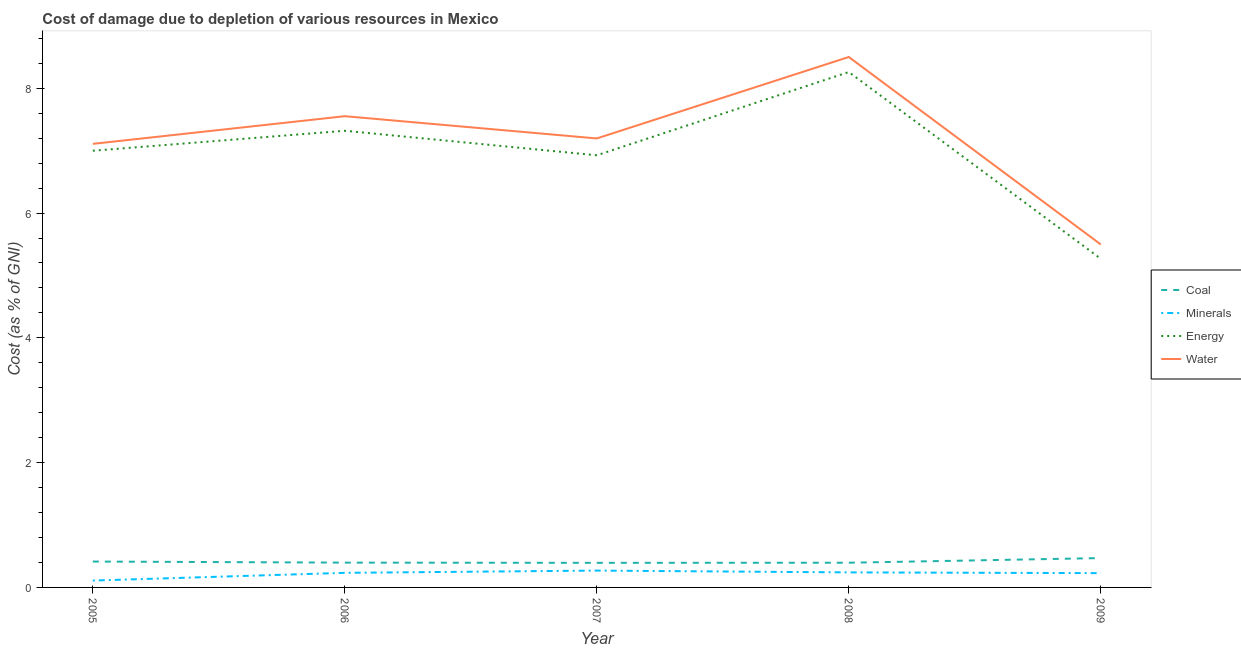How many different coloured lines are there?
Give a very brief answer. 4. Does the line corresponding to cost of damage due to depletion of minerals intersect with the line corresponding to cost of damage due to depletion of energy?
Offer a very short reply. No. Is the number of lines equal to the number of legend labels?
Offer a terse response. Yes. What is the cost of damage due to depletion of minerals in 2005?
Your answer should be very brief. 0.11. Across all years, what is the maximum cost of damage due to depletion of minerals?
Offer a very short reply. 0.27. Across all years, what is the minimum cost of damage due to depletion of energy?
Your response must be concise. 5.27. What is the total cost of damage due to depletion of coal in the graph?
Your answer should be very brief. 2.07. What is the difference between the cost of damage due to depletion of energy in 2006 and that in 2008?
Make the answer very short. -0.94. What is the difference between the cost of damage due to depletion of coal in 2007 and the cost of damage due to depletion of minerals in 2008?
Your answer should be very brief. 0.15. What is the average cost of damage due to depletion of water per year?
Provide a succinct answer. 7.17. In the year 2006, what is the difference between the cost of damage due to depletion of energy and cost of damage due to depletion of water?
Provide a succinct answer. -0.23. In how many years, is the cost of damage due to depletion of minerals greater than 7.2 %?
Provide a succinct answer. 0. What is the ratio of the cost of damage due to depletion of energy in 2005 to that in 2006?
Provide a succinct answer. 0.96. Is the cost of damage due to depletion of coal in 2005 less than that in 2006?
Provide a short and direct response. No. Is the difference between the cost of damage due to depletion of water in 2006 and 2009 greater than the difference between the cost of damage due to depletion of minerals in 2006 and 2009?
Give a very brief answer. Yes. What is the difference between the highest and the second highest cost of damage due to depletion of energy?
Ensure brevity in your answer.  0.94. What is the difference between the highest and the lowest cost of damage due to depletion of water?
Ensure brevity in your answer.  3. Is the sum of the cost of damage due to depletion of water in 2005 and 2009 greater than the maximum cost of damage due to depletion of minerals across all years?
Your answer should be very brief. Yes. Is it the case that in every year, the sum of the cost of damage due to depletion of coal and cost of damage due to depletion of minerals is greater than the cost of damage due to depletion of energy?
Provide a short and direct response. No. Is the cost of damage due to depletion of minerals strictly greater than the cost of damage due to depletion of coal over the years?
Make the answer very short. No. What is the difference between two consecutive major ticks on the Y-axis?
Your answer should be very brief. 2. Where does the legend appear in the graph?
Give a very brief answer. Center right. How are the legend labels stacked?
Offer a very short reply. Vertical. What is the title of the graph?
Provide a succinct answer. Cost of damage due to depletion of various resources in Mexico . What is the label or title of the Y-axis?
Provide a short and direct response. Cost (as % of GNI). What is the Cost (as % of GNI) of Coal in 2005?
Make the answer very short. 0.41. What is the Cost (as % of GNI) of Minerals in 2005?
Your answer should be very brief. 0.11. What is the Cost (as % of GNI) in Energy in 2005?
Your answer should be compact. 7. What is the Cost (as % of GNI) in Water in 2005?
Provide a succinct answer. 7.11. What is the Cost (as % of GNI) of Coal in 2006?
Keep it short and to the point. 0.4. What is the Cost (as % of GNI) of Minerals in 2006?
Your answer should be very brief. 0.23. What is the Cost (as % of GNI) in Energy in 2006?
Make the answer very short. 7.32. What is the Cost (as % of GNI) of Water in 2006?
Provide a short and direct response. 7.55. What is the Cost (as % of GNI) in Coal in 2007?
Your answer should be compact. 0.39. What is the Cost (as % of GNI) in Minerals in 2007?
Keep it short and to the point. 0.27. What is the Cost (as % of GNI) of Energy in 2007?
Offer a terse response. 6.93. What is the Cost (as % of GNI) of Water in 2007?
Your answer should be compact. 7.2. What is the Cost (as % of GNI) of Coal in 2008?
Provide a short and direct response. 0.4. What is the Cost (as % of GNI) in Minerals in 2008?
Provide a short and direct response. 0.24. What is the Cost (as % of GNI) in Energy in 2008?
Provide a short and direct response. 8.26. What is the Cost (as % of GNI) of Water in 2008?
Ensure brevity in your answer.  8.5. What is the Cost (as % of GNI) of Coal in 2009?
Ensure brevity in your answer.  0.47. What is the Cost (as % of GNI) in Minerals in 2009?
Provide a short and direct response. 0.23. What is the Cost (as % of GNI) in Energy in 2009?
Your answer should be compact. 5.27. What is the Cost (as % of GNI) of Water in 2009?
Your response must be concise. 5.5. Across all years, what is the maximum Cost (as % of GNI) in Coal?
Make the answer very short. 0.47. Across all years, what is the maximum Cost (as % of GNI) of Minerals?
Provide a succinct answer. 0.27. Across all years, what is the maximum Cost (as % of GNI) in Energy?
Make the answer very short. 8.26. Across all years, what is the maximum Cost (as % of GNI) in Water?
Offer a very short reply. 8.5. Across all years, what is the minimum Cost (as % of GNI) in Coal?
Your answer should be compact. 0.39. Across all years, what is the minimum Cost (as % of GNI) in Minerals?
Ensure brevity in your answer.  0.11. Across all years, what is the minimum Cost (as % of GNI) in Energy?
Your response must be concise. 5.27. Across all years, what is the minimum Cost (as % of GNI) in Water?
Keep it short and to the point. 5.5. What is the total Cost (as % of GNI) in Coal in the graph?
Give a very brief answer. 2.07. What is the total Cost (as % of GNI) of Minerals in the graph?
Keep it short and to the point. 1.08. What is the total Cost (as % of GNI) in Energy in the graph?
Offer a very short reply. 34.77. What is the total Cost (as % of GNI) of Water in the graph?
Offer a very short reply. 35.86. What is the difference between the Cost (as % of GNI) in Coal in 2005 and that in 2006?
Give a very brief answer. 0.02. What is the difference between the Cost (as % of GNI) in Minerals in 2005 and that in 2006?
Give a very brief answer. -0.12. What is the difference between the Cost (as % of GNI) in Energy in 2005 and that in 2006?
Offer a terse response. -0.32. What is the difference between the Cost (as % of GNI) of Water in 2005 and that in 2006?
Offer a very short reply. -0.44. What is the difference between the Cost (as % of GNI) of Coal in 2005 and that in 2007?
Ensure brevity in your answer.  0.02. What is the difference between the Cost (as % of GNI) of Minerals in 2005 and that in 2007?
Your response must be concise. -0.16. What is the difference between the Cost (as % of GNI) of Energy in 2005 and that in 2007?
Keep it short and to the point. 0.07. What is the difference between the Cost (as % of GNI) in Water in 2005 and that in 2007?
Ensure brevity in your answer.  -0.09. What is the difference between the Cost (as % of GNI) of Coal in 2005 and that in 2008?
Ensure brevity in your answer.  0.02. What is the difference between the Cost (as % of GNI) in Minerals in 2005 and that in 2008?
Offer a terse response. -0.13. What is the difference between the Cost (as % of GNI) of Energy in 2005 and that in 2008?
Offer a terse response. -1.26. What is the difference between the Cost (as % of GNI) in Water in 2005 and that in 2008?
Give a very brief answer. -1.39. What is the difference between the Cost (as % of GNI) in Coal in 2005 and that in 2009?
Offer a terse response. -0.06. What is the difference between the Cost (as % of GNI) of Minerals in 2005 and that in 2009?
Ensure brevity in your answer.  -0.12. What is the difference between the Cost (as % of GNI) in Energy in 2005 and that in 2009?
Offer a very short reply. 1.73. What is the difference between the Cost (as % of GNI) of Water in 2005 and that in 2009?
Make the answer very short. 1.61. What is the difference between the Cost (as % of GNI) of Coal in 2006 and that in 2007?
Provide a short and direct response. 0. What is the difference between the Cost (as % of GNI) of Minerals in 2006 and that in 2007?
Keep it short and to the point. -0.04. What is the difference between the Cost (as % of GNI) of Energy in 2006 and that in 2007?
Give a very brief answer. 0.39. What is the difference between the Cost (as % of GNI) in Water in 2006 and that in 2007?
Your answer should be compact. 0.36. What is the difference between the Cost (as % of GNI) of Coal in 2006 and that in 2008?
Make the answer very short. 0. What is the difference between the Cost (as % of GNI) of Minerals in 2006 and that in 2008?
Your response must be concise. -0.01. What is the difference between the Cost (as % of GNI) of Energy in 2006 and that in 2008?
Give a very brief answer. -0.94. What is the difference between the Cost (as % of GNI) in Water in 2006 and that in 2008?
Provide a short and direct response. -0.95. What is the difference between the Cost (as % of GNI) in Coal in 2006 and that in 2009?
Offer a very short reply. -0.07. What is the difference between the Cost (as % of GNI) of Minerals in 2006 and that in 2009?
Your response must be concise. 0. What is the difference between the Cost (as % of GNI) in Energy in 2006 and that in 2009?
Your response must be concise. 2.05. What is the difference between the Cost (as % of GNI) in Water in 2006 and that in 2009?
Your answer should be compact. 2.06. What is the difference between the Cost (as % of GNI) of Coal in 2007 and that in 2008?
Ensure brevity in your answer.  -0. What is the difference between the Cost (as % of GNI) of Minerals in 2007 and that in 2008?
Provide a short and direct response. 0.03. What is the difference between the Cost (as % of GNI) of Energy in 2007 and that in 2008?
Make the answer very short. -1.33. What is the difference between the Cost (as % of GNI) of Water in 2007 and that in 2008?
Give a very brief answer. -1.31. What is the difference between the Cost (as % of GNI) in Coal in 2007 and that in 2009?
Offer a very short reply. -0.08. What is the difference between the Cost (as % of GNI) of Minerals in 2007 and that in 2009?
Ensure brevity in your answer.  0.04. What is the difference between the Cost (as % of GNI) of Energy in 2007 and that in 2009?
Offer a terse response. 1.66. What is the difference between the Cost (as % of GNI) in Water in 2007 and that in 2009?
Your answer should be compact. 1.7. What is the difference between the Cost (as % of GNI) of Coal in 2008 and that in 2009?
Give a very brief answer. -0.07. What is the difference between the Cost (as % of GNI) of Minerals in 2008 and that in 2009?
Your answer should be very brief. 0.01. What is the difference between the Cost (as % of GNI) of Energy in 2008 and that in 2009?
Keep it short and to the point. 2.99. What is the difference between the Cost (as % of GNI) in Water in 2008 and that in 2009?
Your answer should be very brief. 3. What is the difference between the Cost (as % of GNI) in Coal in 2005 and the Cost (as % of GNI) in Minerals in 2006?
Provide a short and direct response. 0.18. What is the difference between the Cost (as % of GNI) in Coal in 2005 and the Cost (as % of GNI) in Energy in 2006?
Give a very brief answer. -6.9. What is the difference between the Cost (as % of GNI) of Coal in 2005 and the Cost (as % of GNI) of Water in 2006?
Provide a succinct answer. -7.14. What is the difference between the Cost (as % of GNI) in Minerals in 2005 and the Cost (as % of GNI) in Energy in 2006?
Make the answer very short. -7.21. What is the difference between the Cost (as % of GNI) of Minerals in 2005 and the Cost (as % of GNI) of Water in 2006?
Offer a very short reply. -7.44. What is the difference between the Cost (as % of GNI) of Energy in 2005 and the Cost (as % of GNI) of Water in 2006?
Your answer should be compact. -0.55. What is the difference between the Cost (as % of GNI) of Coal in 2005 and the Cost (as % of GNI) of Minerals in 2007?
Keep it short and to the point. 0.14. What is the difference between the Cost (as % of GNI) of Coal in 2005 and the Cost (as % of GNI) of Energy in 2007?
Your answer should be very brief. -6.51. What is the difference between the Cost (as % of GNI) of Coal in 2005 and the Cost (as % of GNI) of Water in 2007?
Offer a terse response. -6.78. What is the difference between the Cost (as % of GNI) of Minerals in 2005 and the Cost (as % of GNI) of Energy in 2007?
Make the answer very short. -6.82. What is the difference between the Cost (as % of GNI) of Minerals in 2005 and the Cost (as % of GNI) of Water in 2007?
Your answer should be compact. -7.09. What is the difference between the Cost (as % of GNI) in Energy in 2005 and the Cost (as % of GNI) in Water in 2007?
Make the answer very short. -0.2. What is the difference between the Cost (as % of GNI) in Coal in 2005 and the Cost (as % of GNI) in Minerals in 2008?
Ensure brevity in your answer.  0.17. What is the difference between the Cost (as % of GNI) in Coal in 2005 and the Cost (as % of GNI) in Energy in 2008?
Offer a very short reply. -7.85. What is the difference between the Cost (as % of GNI) of Coal in 2005 and the Cost (as % of GNI) of Water in 2008?
Make the answer very short. -8.09. What is the difference between the Cost (as % of GNI) in Minerals in 2005 and the Cost (as % of GNI) in Energy in 2008?
Your answer should be very brief. -8.15. What is the difference between the Cost (as % of GNI) in Minerals in 2005 and the Cost (as % of GNI) in Water in 2008?
Your answer should be compact. -8.39. What is the difference between the Cost (as % of GNI) of Energy in 2005 and the Cost (as % of GNI) of Water in 2008?
Offer a terse response. -1.5. What is the difference between the Cost (as % of GNI) of Coal in 2005 and the Cost (as % of GNI) of Minerals in 2009?
Offer a very short reply. 0.19. What is the difference between the Cost (as % of GNI) of Coal in 2005 and the Cost (as % of GNI) of Energy in 2009?
Provide a short and direct response. -4.85. What is the difference between the Cost (as % of GNI) in Coal in 2005 and the Cost (as % of GNI) in Water in 2009?
Provide a succinct answer. -5.08. What is the difference between the Cost (as % of GNI) of Minerals in 2005 and the Cost (as % of GNI) of Energy in 2009?
Provide a succinct answer. -5.16. What is the difference between the Cost (as % of GNI) of Minerals in 2005 and the Cost (as % of GNI) of Water in 2009?
Give a very brief answer. -5.39. What is the difference between the Cost (as % of GNI) of Energy in 2005 and the Cost (as % of GNI) of Water in 2009?
Your response must be concise. 1.5. What is the difference between the Cost (as % of GNI) of Coal in 2006 and the Cost (as % of GNI) of Minerals in 2007?
Make the answer very short. 0.13. What is the difference between the Cost (as % of GNI) of Coal in 2006 and the Cost (as % of GNI) of Energy in 2007?
Ensure brevity in your answer.  -6.53. What is the difference between the Cost (as % of GNI) in Coal in 2006 and the Cost (as % of GNI) in Water in 2007?
Your answer should be very brief. -6.8. What is the difference between the Cost (as % of GNI) of Minerals in 2006 and the Cost (as % of GNI) of Energy in 2007?
Provide a short and direct response. -6.69. What is the difference between the Cost (as % of GNI) of Minerals in 2006 and the Cost (as % of GNI) of Water in 2007?
Your answer should be very brief. -6.96. What is the difference between the Cost (as % of GNI) in Energy in 2006 and the Cost (as % of GNI) in Water in 2007?
Provide a short and direct response. 0.12. What is the difference between the Cost (as % of GNI) in Coal in 2006 and the Cost (as % of GNI) in Minerals in 2008?
Offer a very short reply. 0.16. What is the difference between the Cost (as % of GNI) in Coal in 2006 and the Cost (as % of GNI) in Energy in 2008?
Ensure brevity in your answer.  -7.86. What is the difference between the Cost (as % of GNI) of Coal in 2006 and the Cost (as % of GNI) of Water in 2008?
Give a very brief answer. -8.1. What is the difference between the Cost (as % of GNI) in Minerals in 2006 and the Cost (as % of GNI) in Energy in 2008?
Provide a succinct answer. -8.03. What is the difference between the Cost (as % of GNI) in Minerals in 2006 and the Cost (as % of GNI) in Water in 2008?
Offer a very short reply. -8.27. What is the difference between the Cost (as % of GNI) in Energy in 2006 and the Cost (as % of GNI) in Water in 2008?
Your answer should be compact. -1.18. What is the difference between the Cost (as % of GNI) in Coal in 2006 and the Cost (as % of GNI) in Minerals in 2009?
Offer a very short reply. 0.17. What is the difference between the Cost (as % of GNI) in Coal in 2006 and the Cost (as % of GNI) in Energy in 2009?
Give a very brief answer. -4.87. What is the difference between the Cost (as % of GNI) in Coal in 2006 and the Cost (as % of GNI) in Water in 2009?
Give a very brief answer. -5.1. What is the difference between the Cost (as % of GNI) in Minerals in 2006 and the Cost (as % of GNI) in Energy in 2009?
Offer a terse response. -5.03. What is the difference between the Cost (as % of GNI) of Minerals in 2006 and the Cost (as % of GNI) of Water in 2009?
Provide a short and direct response. -5.26. What is the difference between the Cost (as % of GNI) in Energy in 2006 and the Cost (as % of GNI) in Water in 2009?
Offer a terse response. 1.82. What is the difference between the Cost (as % of GNI) in Coal in 2007 and the Cost (as % of GNI) in Minerals in 2008?
Provide a short and direct response. 0.15. What is the difference between the Cost (as % of GNI) in Coal in 2007 and the Cost (as % of GNI) in Energy in 2008?
Make the answer very short. -7.87. What is the difference between the Cost (as % of GNI) in Coal in 2007 and the Cost (as % of GNI) in Water in 2008?
Your answer should be compact. -8.11. What is the difference between the Cost (as % of GNI) in Minerals in 2007 and the Cost (as % of GNI) in Energy in 2008?
Keep it short and to the point. -7.99. What is the difference between the Cost (as % of GNI) of Minerals in 2007 and the Cost (as % of GNI) of Water in 2008?
Your answer should be very brief. -8.23. What is the difference between the Cost (as % of GNI) in Energy in 2007 and the Cost (as % of GNI) in Water in 2008?
Provide a succinct answer. -1.58. What is the difference between the Cost (as % of GNI) of Coal in 2007 and the Cost (as % of GNI) of Minerals in 2009?
Offer a terse response. 0.17. What is the difference between the Cost (as % of GNI) of Coal in 2007 and the Cost (as % of GNI) of Energy in 2009?
Your response must be concise. -4.87. What is the difference between the Cost (as % of GNI) of Coal in 2007 and the Cost (as % of GNI) of Water in 2009?
Ensure brevity in your answer.  -5.1. What is the difference between the Cost (as % of GNI) of Minerals in 2007 and the Cost (as % of GNI) of Energy in 2009?
Offer a terse response. -5. What is the difference between the Cost (as % of GNI) of Minerals in 2007 and the Cost (as % of GNI) of Water in 2009?
Provide a short and direct response. -5.23. What is the difference between the Cost (as % of GNI) in Energy in 2007 and the Cost (as % of GNI) in Water in 2009?
Your answer should be very brief. 1.43. What is the difference between the Cost (as % of GNI) in Coal in 2008 and the Cost (as % of GNI) in Minerals in 2009?
Ensure brevity in your answer.  0.17. What is the difference between the Cost (as % of GNI) of Coal in 2008 and the Cost (as % of GNI) of Energy in 2009?
Offer a very short reply. -4.87. What is the difference between the Cost (as % of GNI) in Coal in 2008 and the Cost (as % of GNI) in Water in 2009?
Your answer should be very brief. -5.1. What is the difference between the Cost (as % of GNI) of Minerals in 2008 and the Cost (as % of GNI) of Energy in 2009?
Your answer should be very brief. -5.03. What is the difference between the Cost (as % of GNI) in Minerals in 2008 and the Cost (as % of GNI) in Water in 2009?
Provide a short and direct response. -5.26. What is the difference between the Cost (as % of GNI) of Energy in 2008 and the Cost (as % of GNI) of Water in 2009?
Your answer should be very brief. 2.76. What is the average Cost (as % of GNI) of Coal per year?
Your answer should be very brief. 0.41. What is the average Cost (as % of GNI) in Minerals per year?
Offer a terse response. 0.22. What is the average Cost (as % of GNI) of Energy per year?
Offer a very short reply. 6.95. What is the average Cost (as % of GNI) in Water per year?
Your response must be concise. 7.17. In the year 2005, what is the difference between the Cost (as % of GNI) in Coal and Cost (as % of GNI) in Minerals?
Your response must be concise. 0.3. In the year 2005, what is the difference between the Cost (as % of GNI) of Coal and Cost (as % of GNI) of Energy?
Provide a succinct answer. -6.58. In the year 2005, what is the difference between the Cost (as % of GNI) of Coal and Cost (as % of GNI) of Water?
Give a very brief answer. -6.69. In the year 2005, what is the difference between the Cost (as % of GNI) of Minerals and Cost (as % of GNI) of Energy?
Give a very brief answer. -6.89. In the year 2005, what is the difference between the Cost (as % of GNI) in Minerals and Cost (as % of GNI) in Water?
Provide a short and direct response. -7. In the year 2005, what is the difference between the Cost (as % of GNI) in Energy and Cost (as % of GNI) in Water?
Ensure brevity in your answer.  -0.11. In the year 2006, what is the difference between the Cost (as % of GNI) of Coal and Cost (as % of GNI) of Minerals?
Your response must be concise. 0.16. In the year 2006, what is the difference between the Cost (as % of GNI) of Coal and Cost (as % of GNI) of Energy?
Your response must be concise. -6.92. In the year 2006, what is the difference between the Cost (as % of GNI) in Coal and Cost (as % of GNI) in Water?
Your answer should be compact. -7.16. In the year 2006, what is the difference between the Cost (as % of GNI) of Minerals and Cost (as % of GNI) of Energy?
Make the answer very short. -7.09. In the year 2006, what is the difference between the Cost (as % of GNI) in Minerals and Cost (as % of GNI) in Water?
Ensure brevity in your answer.  -7.32. In the year 2006, what is the difference between the Cost (as % of GNI) in Energy and Cost (as % of GNI) in Water?
Keep it short and to the point. -0.23. In the year 2007, what is the difference between the Cost (as % of GNI) of Coal and Cost (as % of GNI) of Minerals?
Provide a short and direct response. 0.12. In the year 2007, what is the difference between the Cost (as % of GNI) in Coal and Cost (as % of GNI) in Energy?
Give a very brief answer. -6.53. In the year 2007, what is the difference between the Cost (as % of GNI) of Coal and Cost (as % of GNI) of Water?
Keep it short and to the point. -6.8. In the year 2007, what is the difference between the Cost (as % of GNI) of Minerals and Cost (as % of GNI) of Energy?
Keep it short and to the point. -6.66. In the year 2007, what is the difference between the Cost (as % of GNI) in Minerals and Cost (as % of GNI) in Water?
Make the answer very short. -6.93. In the year 2007, what is the difference between the Cost (as % of GNI) of Energy and Cost (as % of GNI) of Water?
Your answer should be compact. -0.27. In the year 2008, what is the difference between the Cost (as % of GNI) of Coal and Cost (as % of GNI) of Minerals?
Ensure brevity in your answer.  0.15. In the year 2008, what is the difference between the Cost (as % of GNI) of Coal and Cost (as % of GNI) of Energy?
Offer a very short reply. -7.86. In the year 2008, what is the difference between the Cost (as % of GNI) in Coal and Cost (as % of GNI) in Water?
Offer a terse response. -8.11. In the year 2008, what is the difference between the Cost (as % of GNI) of Minerals and Cost (as % of GNI) of Energy?
Provide a succinct answer. -8.02. In the year 2008, what is the difference between the Cost (as % of GNI) in Minerals and Cost (as % of GNI) in Water?
Your answer should be very brief. -8.26. In the year 2008, what is the difference between the Cost (as % of GNI) of Energy and Cost (as % of GNI) of Water?
Make the answer very short. -0.24. In the year 2009, what is the difference between the Cost (as % of GNI) of Coal and Cost (as % of GNI) of Minerals?
Offer a terse response. 0.24. In the year 2009, what is the difference between the Cost (as % of GNI) in Coal and Cost (as % of GNI) in Energy?
Provide a short and direct response. -4.8. In the year 2009, what is the difference between the Cost (as % of GNI) in Coal and Cost (as % of GNI) in Water?
Provide a succinct answer. -5.03. In the year 2009, what is the difference between the Cost (as % of GNI) in Minerals and Cost (as % of GNI) in Energy?
Give a very brief answer. -5.04. In the year 2009, what is the difference between the Cost (as % of GNI) of Minerals and Cost (as % of GNI) of Water?
Your response must be concise. -5.27. In the year 2009, what is the difference between the Cost (as % of GNI) of Energy and Cost (as % of GNI) of Water?
Ensure brevity in your answer.  -0.23. What is the ratio of the Cost (as % of GNI) in Coal in 2005 to that in 2006?
Offer a very short reply. 1.04. What is the ratio of the Cost (as % of GNI) in Minerals in 2005 to that in 2006?
Ensure brevity in your answer.  0.47. What is the ratio of the Cost (as % of GNI) of Energy in 2005 to that in 2006?
Your answer should be compact. 0.96. What is the ratio of the Cost (as % of GNI) in Water in 2005 to that in 2006?
Provide a short and direct response. 0.94. What is the ratio of the Cost (as % of GNI) of Coal in 2005 to that in 2007?
Your response must be concise. 1.05. What is the ratio of the Cost (as % of GNI) of Minerals in 2005 to that in 2007?
Provide a succinct answer. 0.41. What is the ratio of the Cost (as % of GNI) in Energy in 2005 to that in 2007?
Give a very brief answer. 1.01. What is the ratio of the Cost (as % of GNI) in Water in 2005 to that in 2007?
Your answer should be very brief. 0.99. What is the ratio of the Cost (as % of GNI) of Coal in 2005 to that in 2008?
Your answer should be very brief. 1.05. What is the ratio of the Cost (as % of GNI) of Minerals in 2005 to that in 2008?
Keep it short and to the point. 0.46. What is the ratio of the Cost (as % of GNI) of Energy in 2005 to that in 2008?
Provide a succinct answer. 0.85. What is the ratio of the Cost (as % of GNI) of Water in 2005 to that in 2008?
Give a very brief answer. 0.84. What is the ratio of the Cost (as % of GNI) in Coal in 2005 to that in 2009?
Keep it short and to the point. 0.88. What is the ratio of the Cost (as % of GNI) in Minerals in 2005 to that in 2009?
Offer a very short reply. 0.48. What is the ratio of the Cost (as % of GNI) of Energy in 2005 to that in 2009?
Offer a terse response. 1.33. What is the ratio of the Cost (as % of GNI) in Water in 2005 to that in 2009?
Offer a terse response. 1.29. What is the ratio of the Cost (as % of GNI) in Coal in 2006 to that in 2007?
Your response must be concise. 1.01. What is the ratio of the Cost (as % of GNI) of Minerals in 2006 to that in 2007?
Give a very brief answer. 0.87. What is the ratio of the Cost (as % of GNI) of Energy in 2006 to that in 2007?
Your response must be concise. 1.06. What is the ratio of the Cost (as % of GNI) of Water in 2006 to that in 2007?
Make the answer very short. 1.05. What is the ratio of the Cost (as % of GNI) in Minerals in 2006 to that in 2008?
Your response must be concise. 0.97. What is the ratio of the Cost (as % of GNI) of Energy in 2006 to that in 2008?
Your response must be concise. 0.89. What is the ratio of the Cost (as % of GNI) of Water in 2006 to that in 2008?
Your answer should be very brief. 0.89. What is the ratio of the Cost (as % of GNI) in Coal in 2006 to that in 2009?
Offer a terse response. 0.84. What is the ratio of the Cost (as % of GNI) in Minerals in 2006 to that in 2009?
Keep it short and to the point. 1.02. What is the ratio of the Cost (as % of GNI) in Energy in 2006 to that in 2009?
Offer a very short reply. 1.39. What is the ratio of the Cost (as % of GNI) of Water in 2006 to that in 2009?
Give a very brief answer. 1.37. What is the ratio of the Cost (as % of GNI) of Coal in 2007 to that in 2008?
Provide a succinct answer. 1. What is the ratio of the Cost (as % of GNI) in Minerals in 2007 to that in 2008?
Offer a very short reply. 1.12. What is the ratio of the Cost (as % of GNI) in Energy in 2007 to that in 2008?
Make the answer very short. 0.84. What is the ratio of the Cost (as % of GNI) of Water in 2007 to that in 2008?
Make the answer very short. 0.85. What is the ratio of the Cost (as % of GNI) in Coal in 2007 to that in 2009?
Offer a very short reply. 0.84. What is the ratio of the Cost (as % of GNI) in Minerals in 2007 to that in 2009?
Your answer should be compact. 1.18. What is the ratio of the Cost (as % of GNI) in Energy in 2007 to that in 2009?
Offer a terse response. 1.31. What is the ratio of the Cost (as % of GNI) in Water in 2007 to that in 2009?
Your answer should be compact. 1.31. What is the ratio of the Cost (as % of GNI) of Coal in 2008 to that in 2009?
Offer a terse response. 0.84. What is the ratio of the Cost (as % of GNI) in Minerals in 2008 to that in 2009?
Offer a terse response. 1.05. What is the ratio of the Cost (as % of GNI) in Energy in 2008 to that in 2009?
Your answer should be compact. 1.57. What is the ratio of the Cost (as % of GNI) in Water in 2008 to that in 2009?
Make the answer very short. 1.55. What is the difference between the highest and the second highest Cost (as % of GNI) of Coal?
Ensure brevity in your answer.  0.06. What is the difference between the highest and the second highest Cost (as % of GNI) in Minerals?
Provide a succinct answer. 0.03. What is the difference between the highest and the second highest Cost (as % of GNI) in Energy?
Provide a succinct answer. 0.94. What is the difference between the highest and the second highest Cost (as % of GNI) of Water?
Provide a succinct answer. 0.95. What is the difference between the highest and the lowest Cost (as % of GNI) in Coal?
Offer a terse response. 0.08. What is the difference between the highest and the lowest Cost (as % of GNI) of Minerals?
Your response must be concise. 0.16. What is the difference between the highest and the lowest Cost (as % of GNI) in Energy?
Offer a terse response. 2.99. What is the difference between the highest and the lowest Cost (as % of GNI) of Water?
Make the answer very short. 3. 